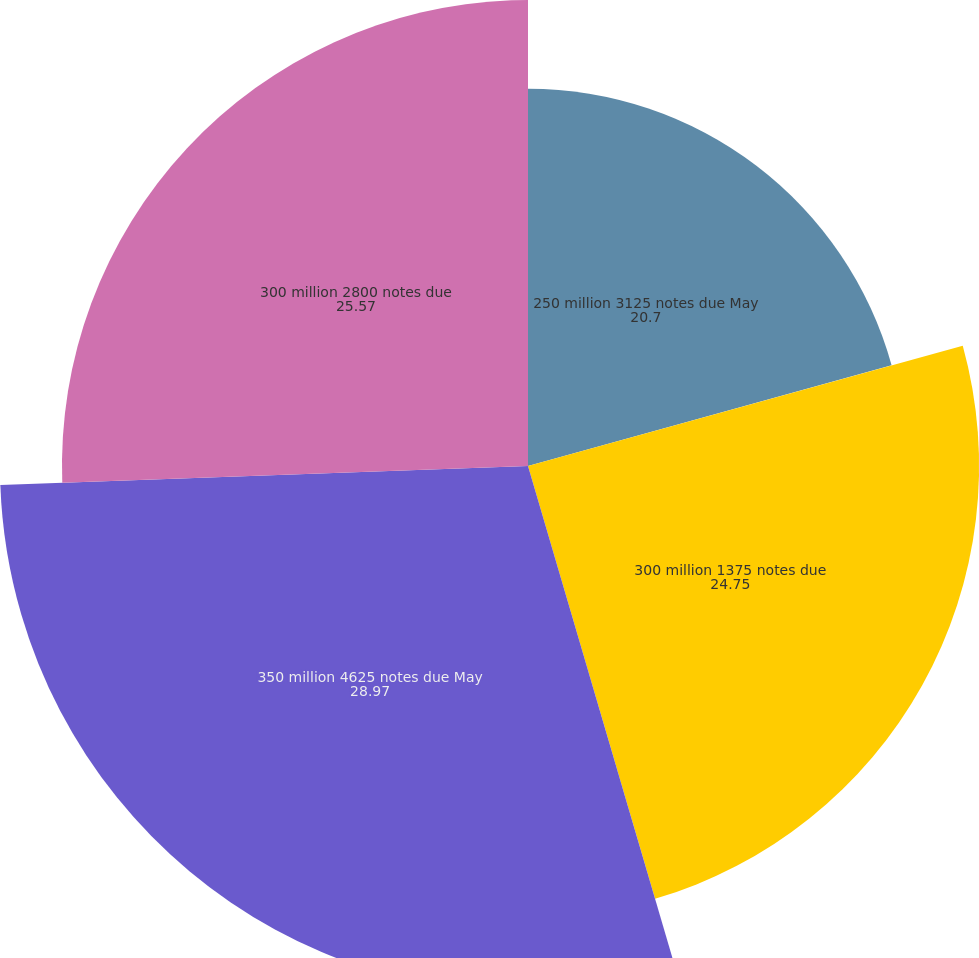Convert chart to OTSL. <chart><loc_0><loc_0><loc_500><loc_500><pie_chart><fcel>250 million 3125 notes due May<fcel>300 million 1375 notes due<fcel>350 million 4625 notes due May<fcel>300 million 2800 notes due<nl><fcel>20.7%<fcel>24.75%<fcel>28.97%<fcel>25.57%<nl></chart> 